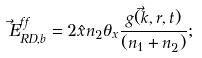Convert formula to latex. <formula><loc_0><loc_0><loc_500><loc_500>\vec { E } ^ { f f } _ { R D , b } = 2 \hat { x } n _ { 2 } \theta _ { x } \frac { g ( \vec { k } , r , t ) } { ( n _ { 1 } + n _ { 2 } ) } ;</formula> 